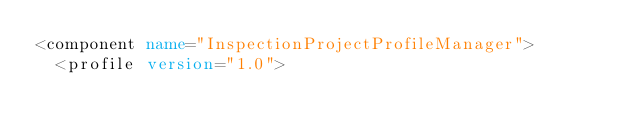<code> <loc_0><loc_0><loc_500><loc_500><_XML_><component name="InspectionProjectProfileManager">
  <profile version="1.0"></code> 